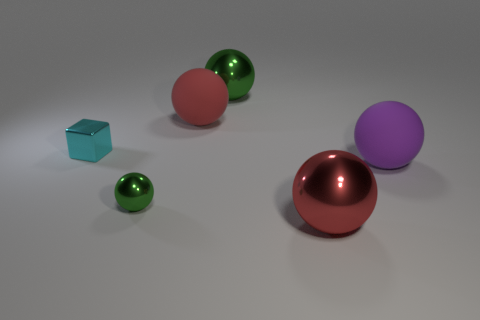Subtract all tiny green balls. How many balls are left? 4 Subtract all blue cubes. How many green balls are left? 2 Add 2 purple spheres. How many objects exist? 8 Subtract all green balls. How many balls are left? 3 Subtract 2 balls. How many balls are left? 3 Subtract all green balls. Subtract all yellow cubes. How many balls are left? 3 Subtract all spheres. How many objects are left? 1 Subtract all big shiny balls. Subtract all large rubber balls. How many objects are left? 2 Add 2 cyan metallic cubes. How many cyan metallic cubes are left? 3 Add 5 cyan spheres. How many cyan spheres exist? 5 